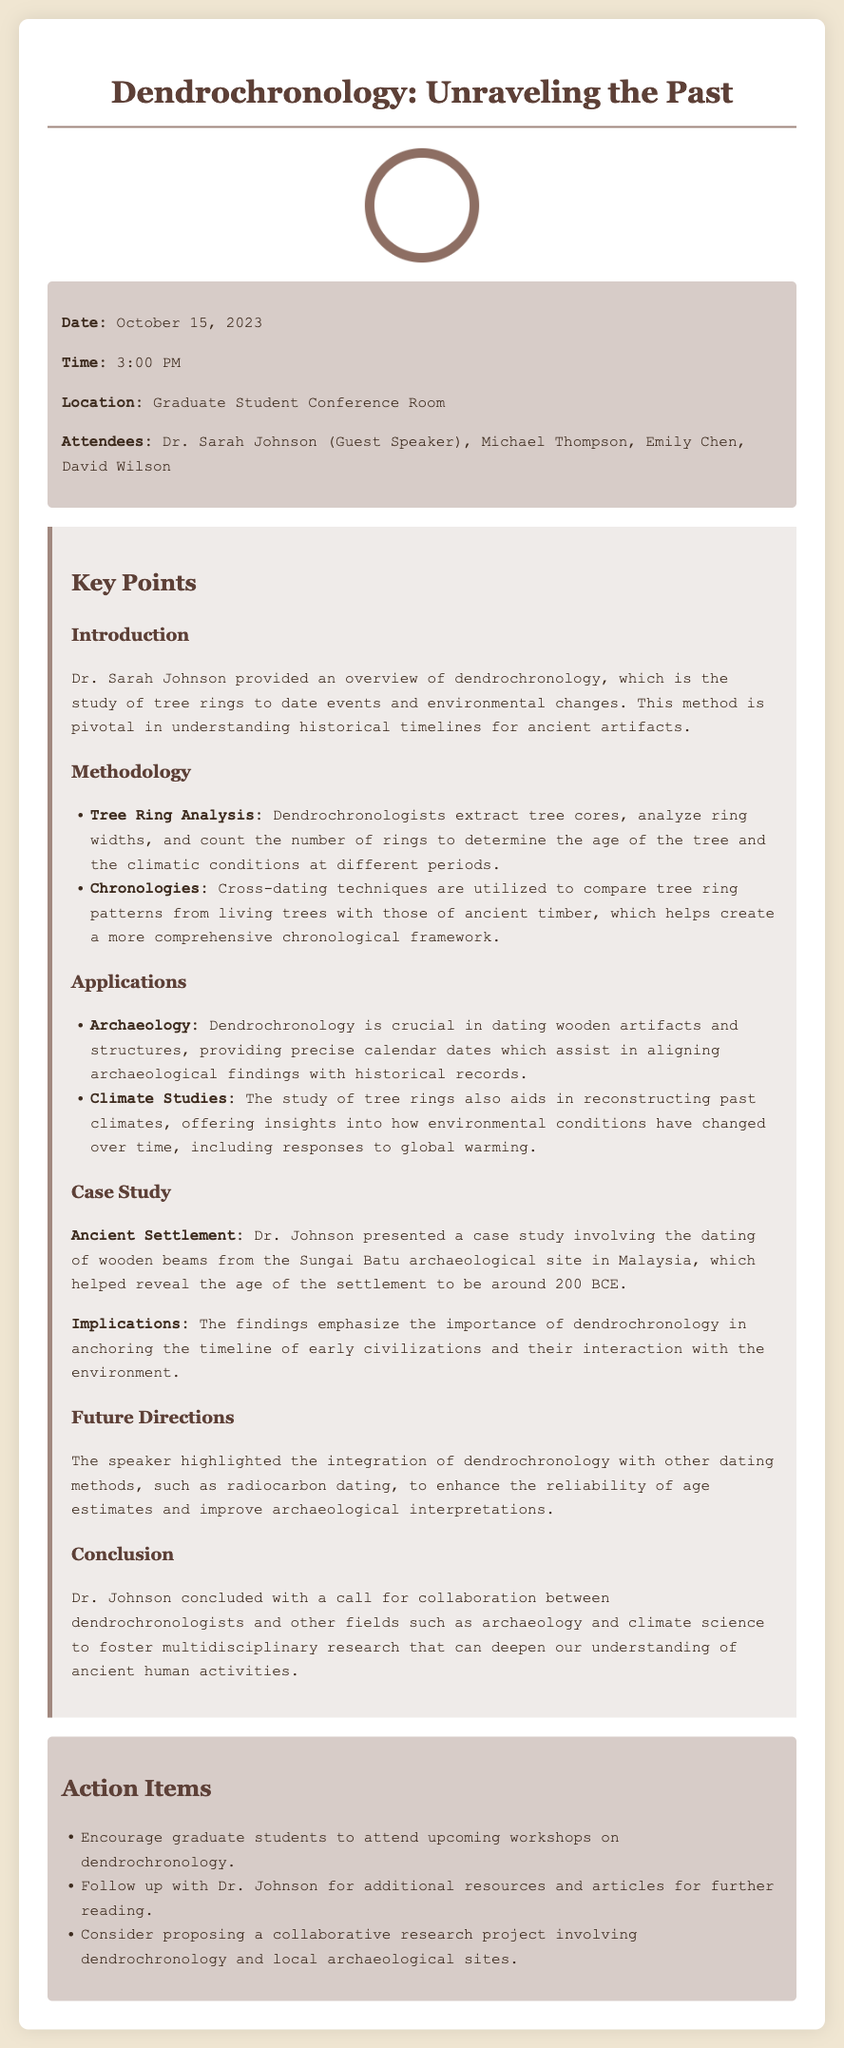What is the date of the presentation? The date of the presentation is mentioned in the meta-info section of the document.
Answer: October 15, 2023 Who was the guest speaker? The guest speaker's name is provided in the list of attendees within the meta-info.
Answer: Dr. Sarah Johnson What is dendrochronology primarily used for? The key points outline the main purposes of dendrochronology.
Answer: Dating events and environmental changes What archaeological site was discussed in the case study? The case study section specifies the archaeological site that was analyzed during the presentation.
Answer: Sungai Batu What is one application of dendrochronology mentioned in the document? The applications section lists various uses for dendrochronology.
Answer: Dating wooden artifacts How does dendrochronology enhance reliability according to the future directions? The document outlines potential future advancements that improve age estimates and interpretations.
Answer: Integration with other dating methods What is one action item suggested in the meeting? The action items section lists suggested tasks to follow up on the presentation.
Answer: Encourage graduate students to attend upcoming workshops How does Dr. Johnson suggest collaboration can benefit research? The conclusion indicates a call for collaboration between different fields to deepen understanding.
Answer: Foster multidisciplinary research 